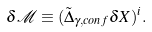<formula> <loc_0><loc_0><loc_500><loc_500>\delta \mathcal { M } \equiv ( \tilde { \Delta } _ { \gamma , c o n f } \delta X ) ^ { i } .</formula> 